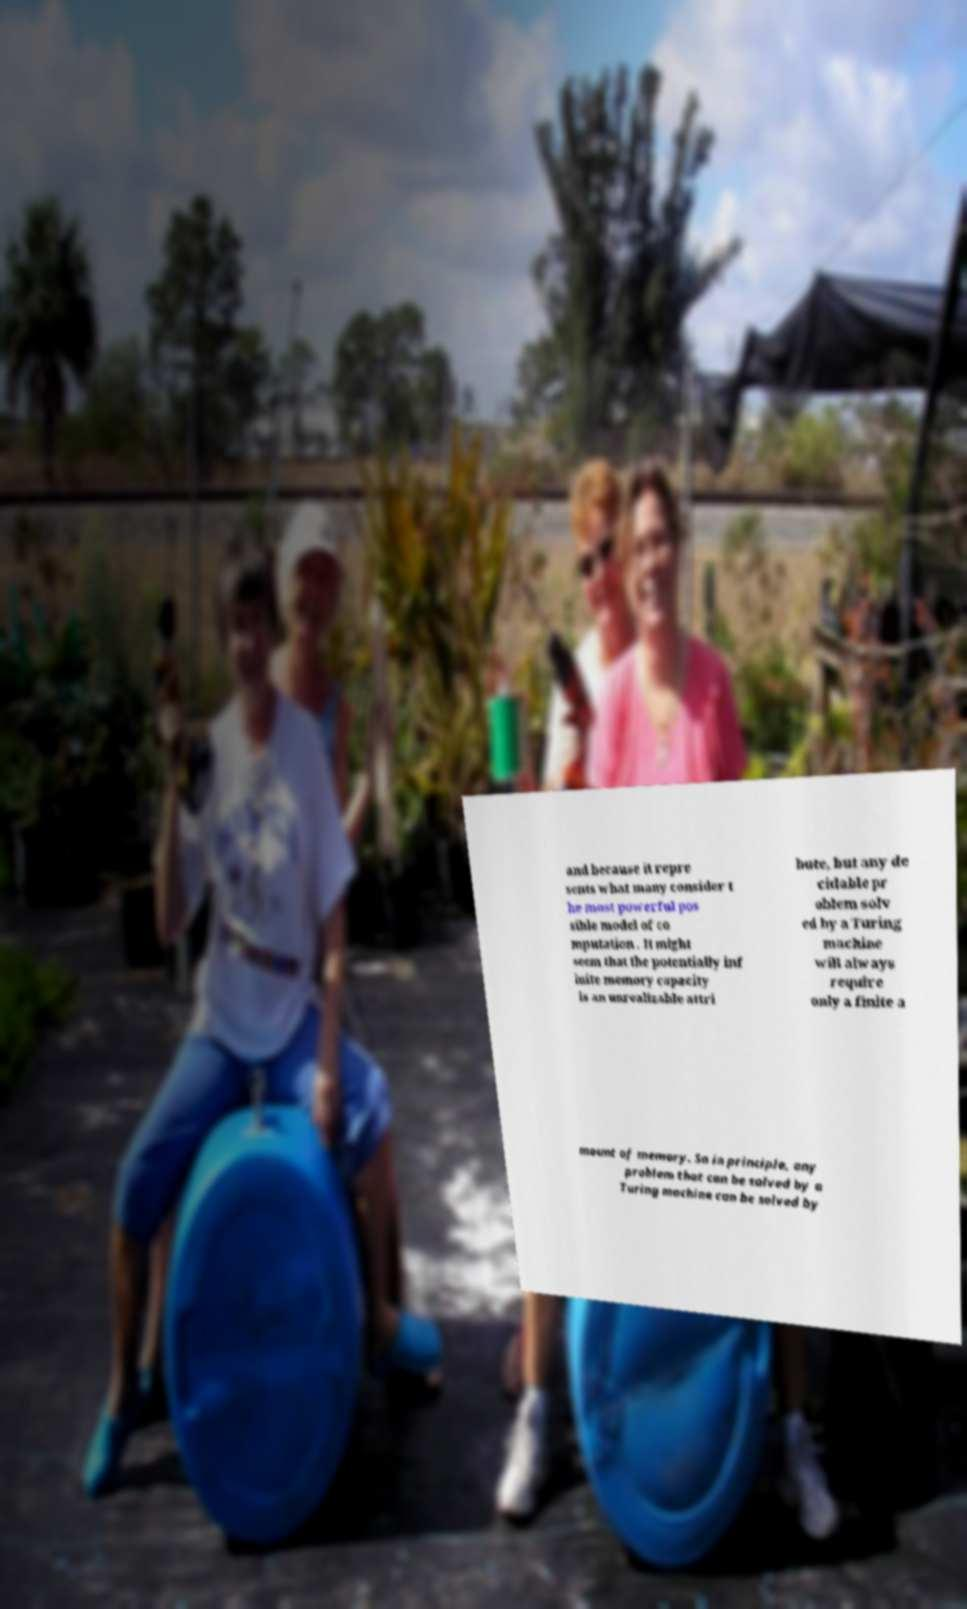Can you read and provide the text displayed in the image?This photo seems to have some interesting text. Can you extract and type it out for me? and because it repre sents what many consider t he most powerful pos sible model of co mputation . It might seem that the potentially inf inite memory capacity is an unrealizable attri bute, but any de cidable pr oblem solv ed by a Turing machine will always require only a finite a mount of memory. So in principle, any problem that can be solved by a Turing machine can be solved by 